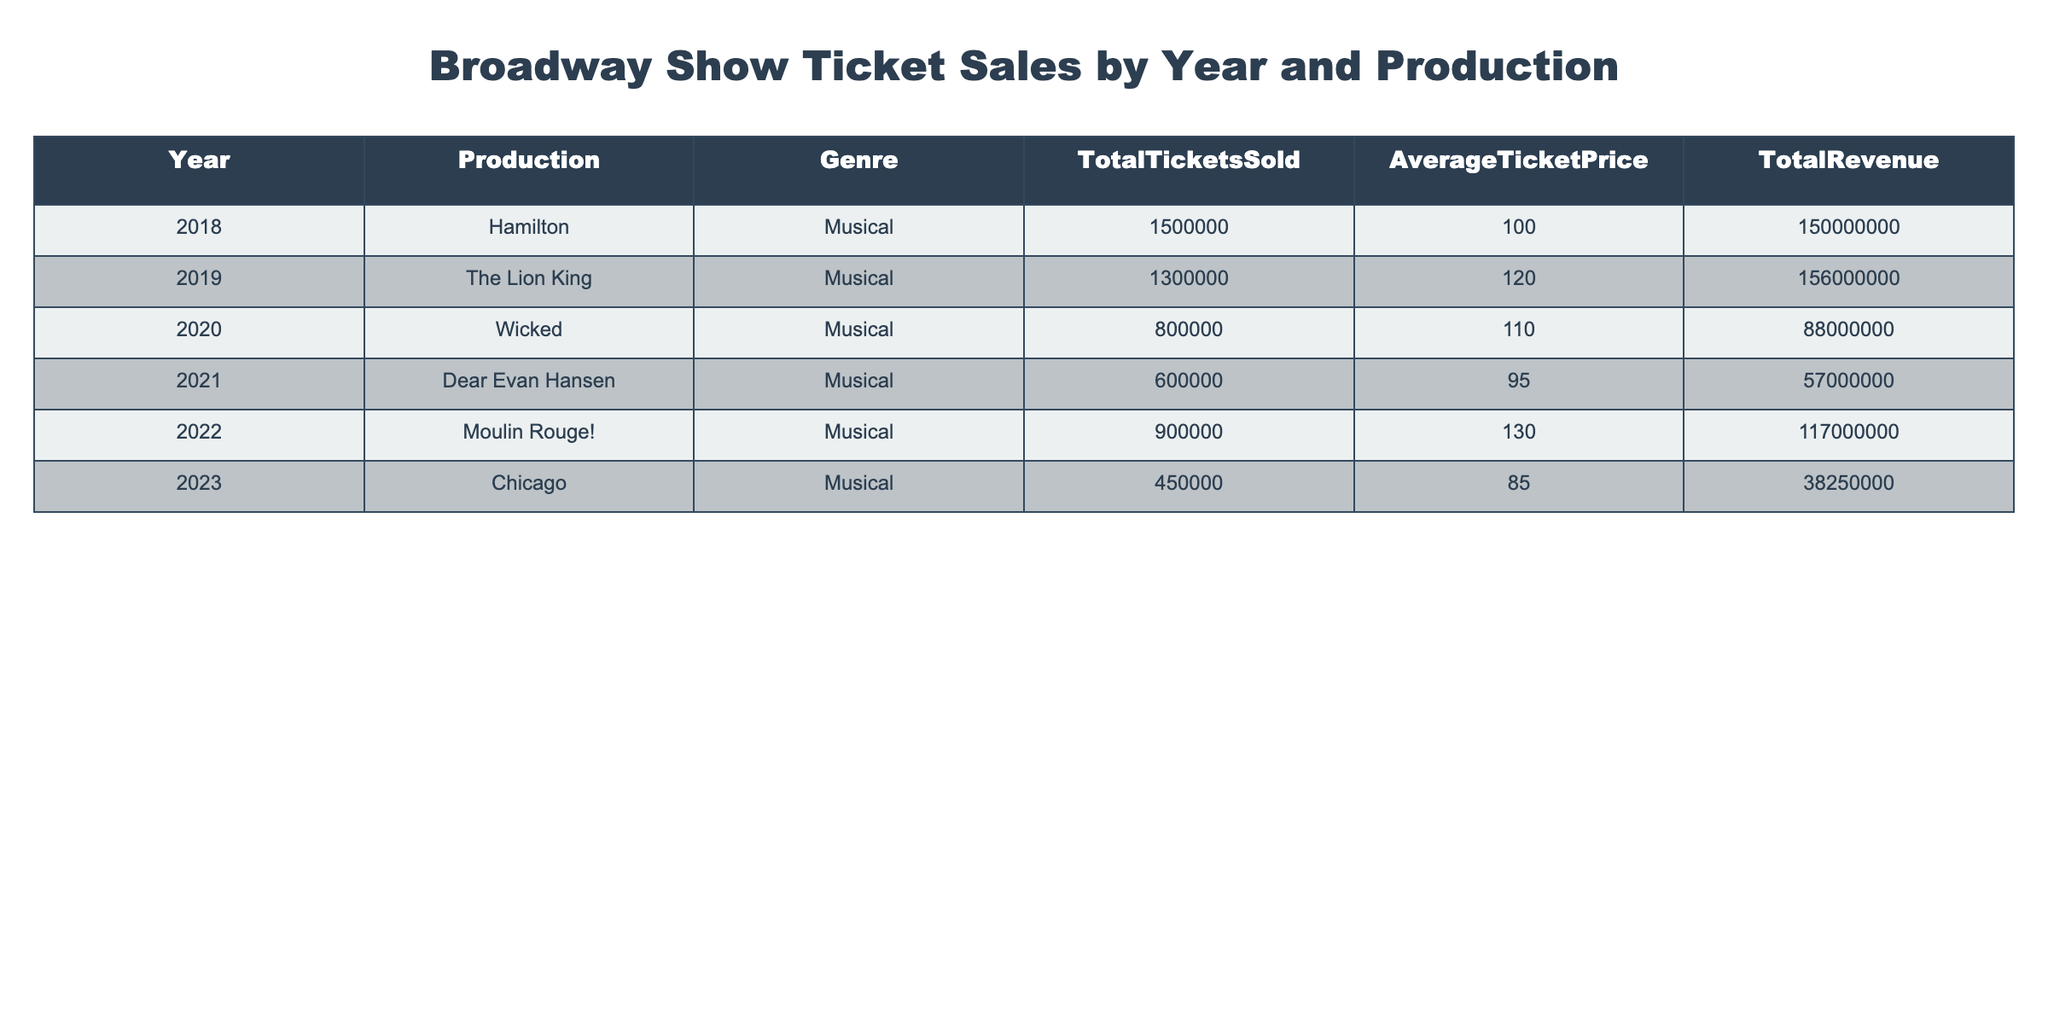What was the total revenue for "Wicked" in 2020? The table shows "Wicked" with a total revenue of 88000000 for the year 2020.
Answer: 88000000 Which production had the highest average ticket price? Looking at the Average Ticket Price column, "Moulin Rouge!" in 2022 has the highest average ticket price at 130.
Answer: 130 How many tickets were sold for "Dear Evan Hansen" in 2021 compared to "Chicago" in 2023? "Dear Evan Hansen" sold 600000 tickets in 2021, while "Chicago" sold 450000 tickets in 2023. The difference is 600000 - 450000 = 150000 tickets more for "Dear Evan Hansen."
Answer: 150000 Was the total revenue for "The Lion King" greater than that of "Hamilton"? "The Lion King" had a total revenue of 156000000, while "Hamilton" had a total revenue of 150000000. Since 156000000 is greater than 150000000, the statement is true.
Answer: Yes What is the total number of tickets sold across all productions from 2018 to 2023? Summing the tickets sold: 1500000 (Hamilton) + 1300000 (The Lion King) + 800000 (Wicked) + 600000 (Dear Evan Hansen) + 900000 (Moulin Rouge!) + 450000 (Chicago) gives a total of 1500000 + 1300000 + 800000 + 600000 + 900000 + 450000 =  1530000 tickets sold.
Answer: 1530000 What was the average ticket price for all productions in 2022 and 2023? The average ticket prices for 2022 and 2023 were 130 and 85, respectively. To find the average for these years: (130 + 85) / 2 = 107.5.
Answer: 107.5 Did "Moulin Rouge!" in 2022 sell more tickets than "Wicked" in 2020? "Moulin Rouge!" sold 900000 tickets while "Wicked" sold 800000 tickets in their respective years. Since 900000 is greater than 800000, the statement is true.
Answer: Yes Which genre had the highest total revenue across all years? Adding the total revenue for each production: 150000000 (Hamilton) + 156000000 (The Lion King) + 88000000 (Wicked) + 57000000 (Dear Evan Hansen) + 117000000 (Moulin Rouge!) + 38250000 (Chicago) gives a total revenue of 150000000 + 156000000 + 88000000 + 57000000 + 117000000 + 38250000 =  579500000. Since all productions are musicals, the highest total revenue is 579500000 for the musical genre.
Answer: 579500000 